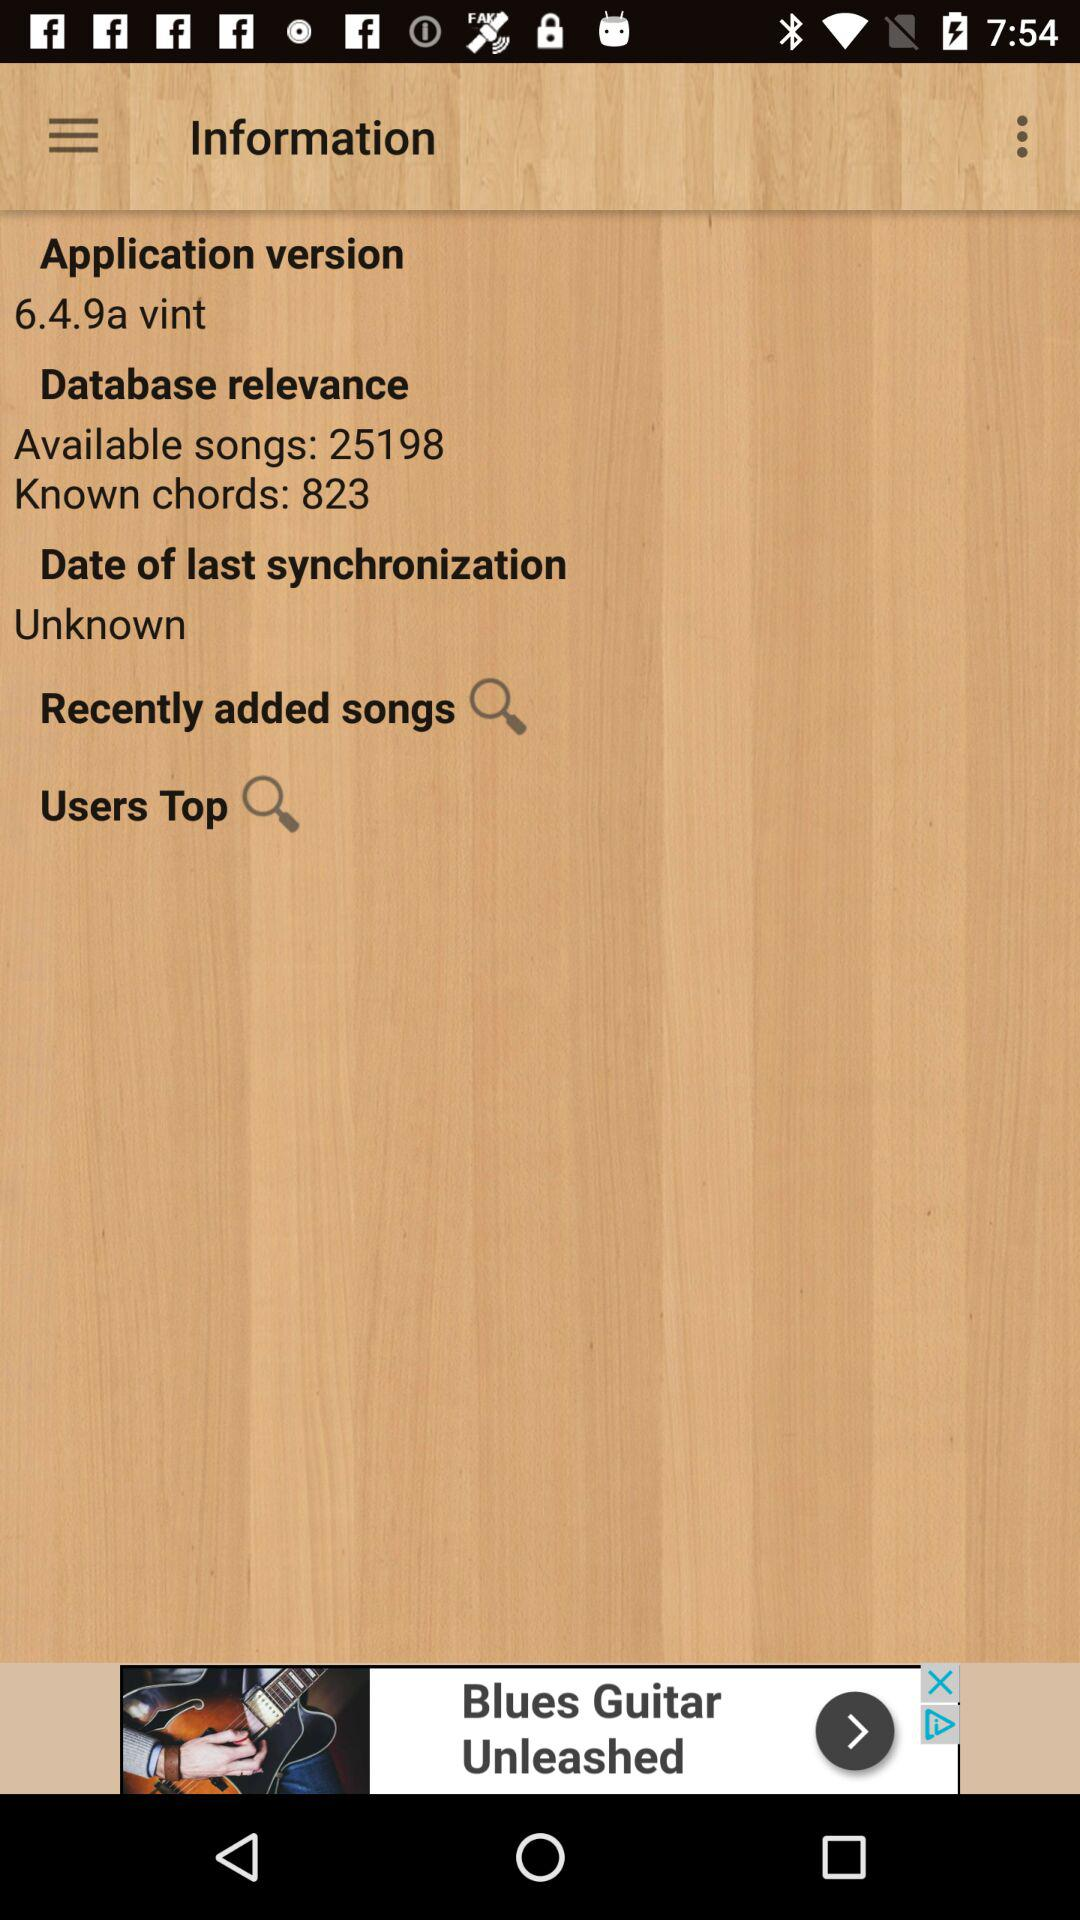How many songs are there available? There are 25198 songs available. 